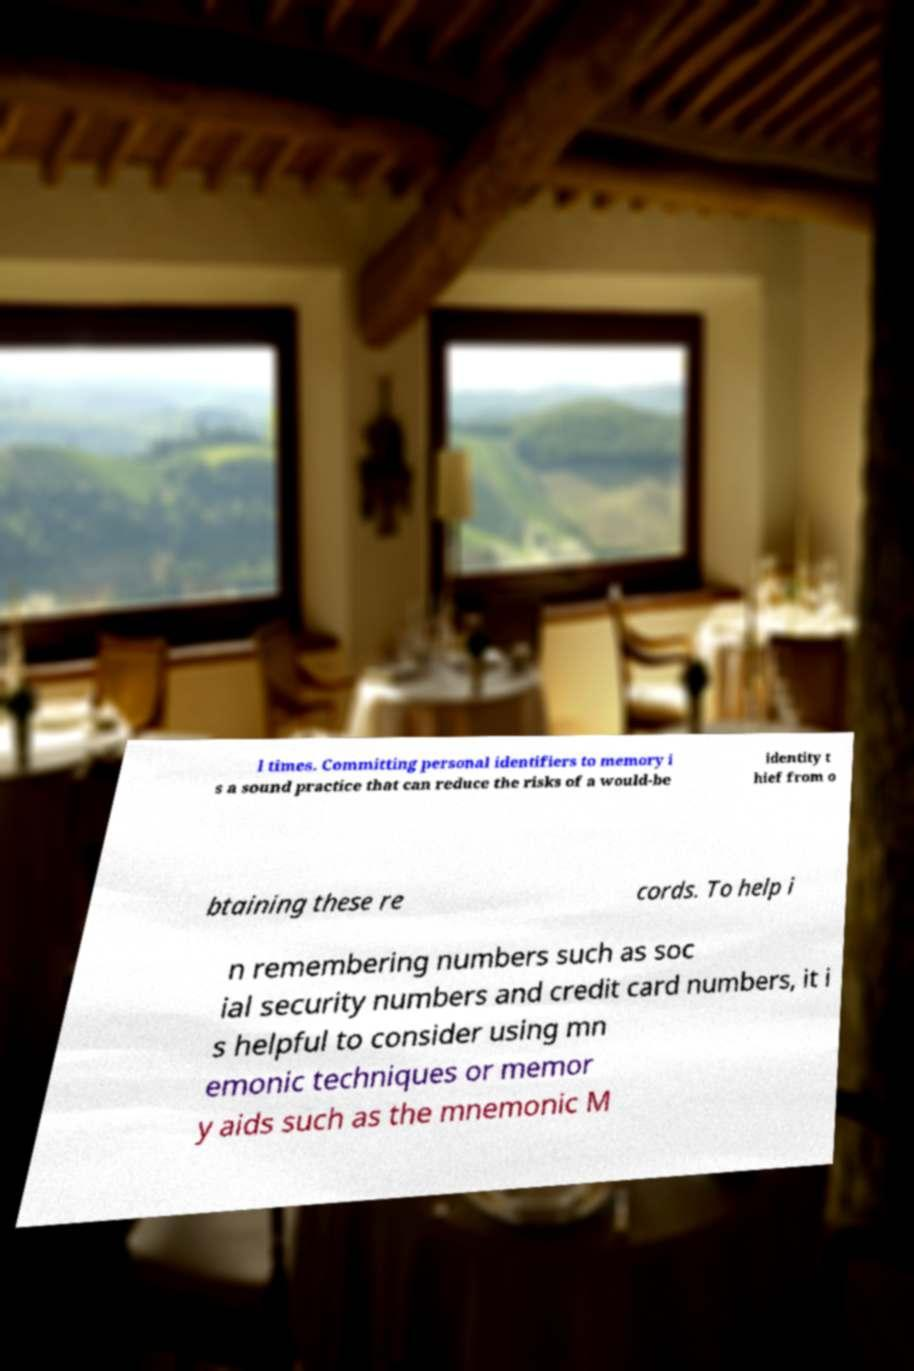I need the written content from this picture converted into text. Can you do that? l times. Committing personal identifiers to memory i s a sound practice that can reduce the risks of a would-be identity t hief from o btaining these re cords. To help i n remembering numbers such as soc ial security numbers and credit card numbers, it i s helpful to consider using mn emonic techniques or memor y aids such as the mnemonic M 